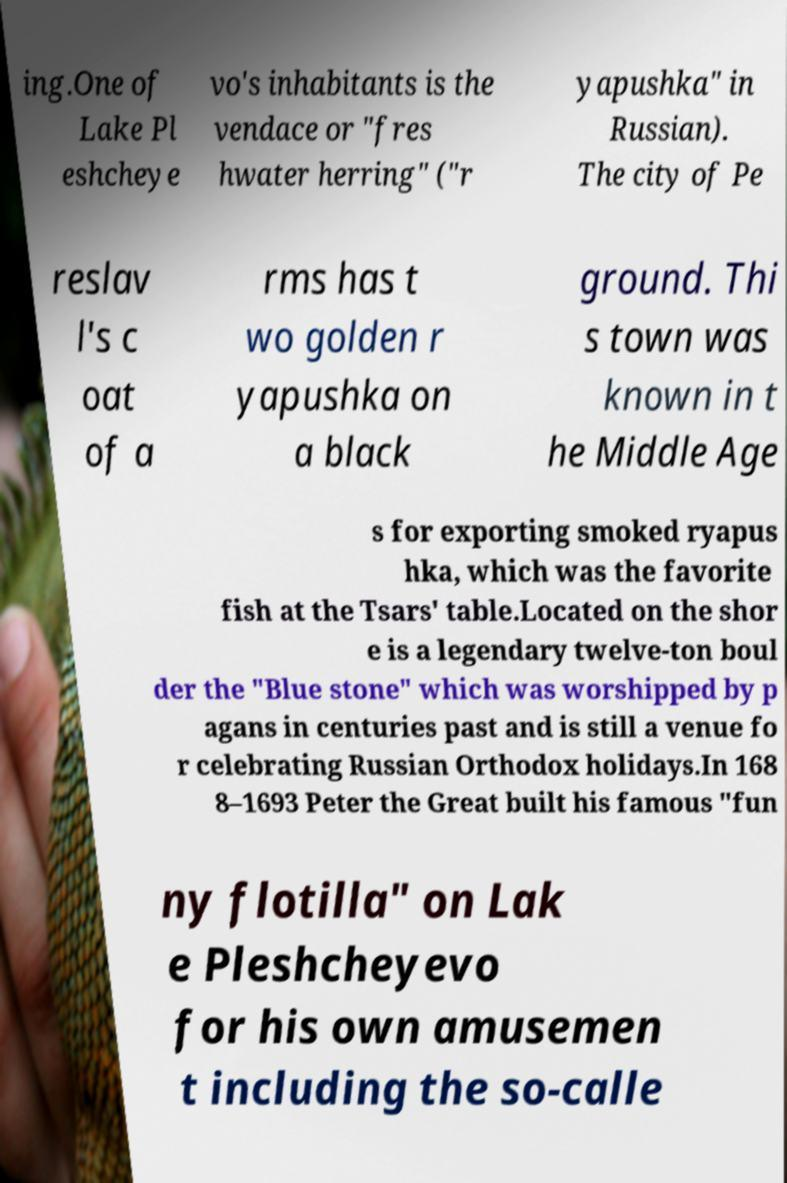There's text embedded in this image that I need extracted. Can you transcribe it verbatim? ing.One of Lake Pl eshcheye vo's inhabitants is the vendace or "fres hwater herring" ("r yapushka" in Russian). The city of Pe reslav l's c oat of a rms has t wo golden r yapushka on a black ground. Thi s town was known in t he Middle Age s for exporting smoked ryapus hka, which was the favorite fish at the Tsars' table.Located on the shor e is a legendary twelve-ton boul der the "Blue stone" which was worshipped by p agans in centuries past and is still a venue fo r celebrating Russian Orthodox holidays.In 168 8–1693 Peter the Great built his famous "fun ny flotilla" on Lak e Pleshcheyevo for his own amusemen t including the so-calle 